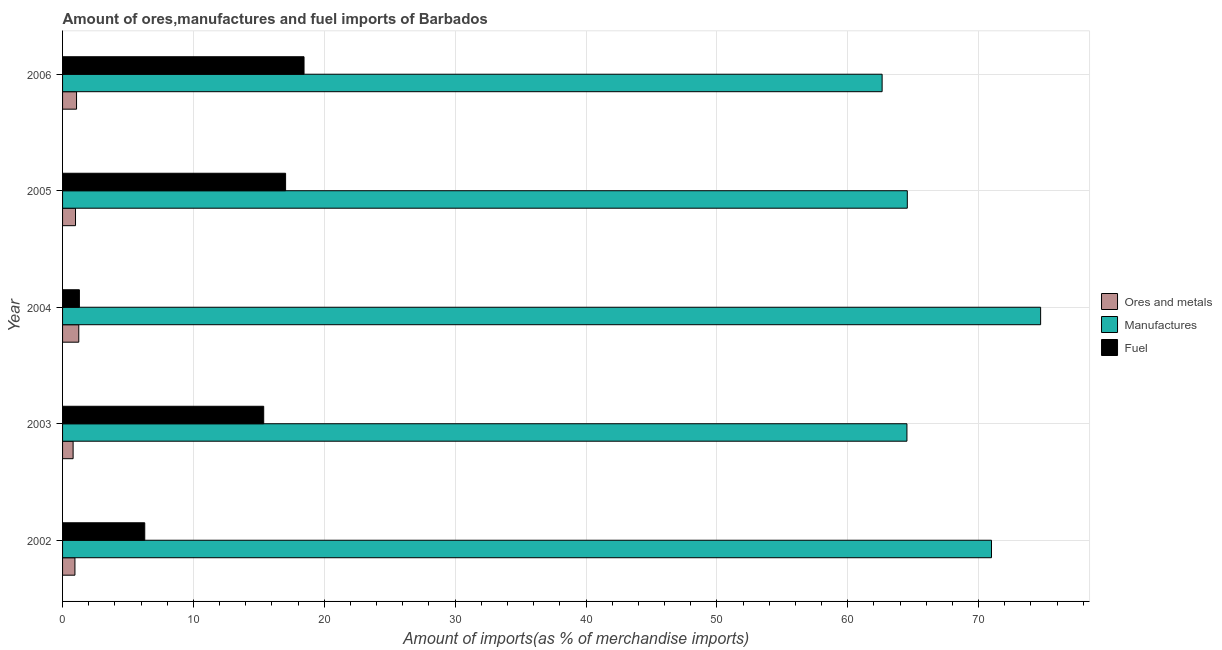How many groups of bars are there?
Your response must be concise. 5. Are the number of bars on each tick of the Y-axis equal?
Offer a terse response. Yes. How many bars are there on the 5th tick from the top?
Offer a very short reply. 3. How many bars are there on the 3rd tick from the bottom?
Your response must be concise. 3. In how many cases, is the number of bars for a given year not equal to the number of legend labels?
Give a very brief answer. 0. What is the percentage of fuel imports in 2004?
Give a very brief answer. 1.29. Across all years, what is the maximum percentage of ores and metals imports?
Make the answer very short. 1.24. Across all years, what is the minimum percentage of ores and metals imports?
Ensure brevity in your answer.  0.81. In which year was the percentage of ores and metals imports minimum?
Ensure brevity in your answer.  2003. What is the total percentage of manufactures imports in the graph?
Keep it short and to the point. 337.42. What is the difference between the percentage of ores and metals imports in 2003 and that in 2004?
Your answer should be very brief. -0.43. What is the difference between the percentage of ores and metals imports in 2004 and the percentage of manufactures imports in 2002?
Offer a very short reply. -69.74. What is the average percentage of manufactures imports per year?
Offer a terse response. 67.48. In the year 2003, what is the difference between the percentage of manufactures imports and percentage of ores and metals imports?
Your answer should be compact. 63.72. In how many years, is the percentage of manufactures imports greater than 12 %?
Offer a very short reply. 5. What is the ratio of the percentage of fuel imports in 2002 to that in 2005?
Offer a terse response. 0.37. Is the difference between the percentage of manufactures imports in 2005 and 2006 greater than the difference between the percentage of ores and metals imports in 2005 and 2006?
Give a very brief answer. Yes. What is the difference between the highest and the second highest percentage of fuel imports?
Give a very brief answer. 1.41. What is the difference between the highest and the lowest percentage of manufactures imports?
Keep it short and to the point. 12.11. What does the 2nd bar from the top in 2002 represents?
Your answer should be compact. Manufactures. What does the 1st bar from the bottom in 2003 represents?
Ensure brevity in your answer.  Ores and metals. Is it the case that in every year, the sum of the percentage of ores and metals imports and percentage of manufactures imports is greater than the percentage of fuel imports?
Make the answer very short. Yes. Are all the bars in the graph horizontal?
Your answer should be compact. Yes. Where does the legend appear in the graph?
Give a very brief answer. Center right. What is the title of the graph?
Keep it short and to the point. Amount of ores,manufactures and fuel imports of Barbados. Does "Taxes on income" appear as one of the legend labels in the graph?
Your response must be concise. No. What is the label or title of the X-axis?
Your response must be concise. Amount of imports(as % of merchandise imports). What is the Amount of imports(as % of merchandise imports) in Ores and metals in 2002?
Offer a terse response. 0.95. What is the Amount of imports(as % of merchandise imports) in Manufactures in 2002?
Keep it short and to the point. 70.98. What is the Amount of imports(as % of merchandise imports) in Fuel in 2002?
Offer a terse response. 6.28. What is the Amount of imports(as % of merchandise imports) in Ores and metals in 2003?
Provide a short and direct response. 0.81. What is the Amount of imports(as % of merchandise imports) of Manufactures in 2003?
Your answer should be compact. 64.52. What is the Amount of imports(as % of merchandise imports) of Fuel in 2003?
Give a very brief answer. 15.37. What is the Amount of imports(as % of merchandise imports) in Ores and metals in 2004?
Ensure brevity in your answer.  1.24. What is the Amount of imports(as % of merchandise imports) of Manufactures in 2004?
Offer a terse response. 74.74. What is the Amount of imports(as % of merchandise imports) of Fuel in 2004?
Keep it short and to the point. 1.29. What is the Amount of imports(as % of merchandise imports) of Ores and metals in 2005?
Give a very brief answer. 0.99. What is the Amount of imports(as % of merchandise imports) of Manufactures in 2005?
Your answer should be compact. 64.55. What is the Amount of imports(as % of merchandise imports) of Fuel in 2005?
Offer a terse response. 17.04. What is the Amount of imports(as % of merchandise imports) in Ores and metals in 2006?
Your answer should be compact. 1.07. What is the Amount of imports(as % of merchandise imports) in Manufactures in 2006?
Ensure brevity in your answer.  62.63. What is the Amount of imports(as % of merchandise imports) in Fuel in 2006?
Your response must be concise. 18.45. Across all years, what is the maximum Amount of imports(as % of merchandise imports) of Ores and metals?
Offer a very short reply. 1.24. Across all years, what is the maximum Amount of imports(as % of merchandise imports) in Manufactures?
Make the answer very short. 74.74. Across all years, what is the maximum Amount of imports(as % of merchandise imports) in Fuel?
Your response must be concise. 18.45. Across all years, what is the minimum Amount of imports(as % of merchandise imports) in Ores and metals?
Offer a very short reply. 0.81. Across all years, what is the minimum Amount of imports(as % of merchandise imports) of Manufactures?
Keep it short and to the point. 62.63. Across all years, what is the minimum Amount of imports(as % of merchandise imports) of Fuel?
Offer a very short reply. 1.29. What is the total Amount of imports(as % of merchandise imports) of Ores and metals in the graph?
Keep it short and to the point. 5.05. What is the total Amount of imports(as % of merchandise imports) in Manufactures in the graph?
Your answer should be very brief. 337.42. What is the total Amount of imports(as % of merchandise imports) of Fuel in the graph?
Provide a short and direct response. 58.43. What is the difference between the Amount of imports(as % of merchandise imports) of Ores and metals in 2002 and that in 2003?
Provide a short and direct response. 0.14. What is the difference between the Amount of imports(as % of merchandise imports) in Manufactures in 2002 and that in 2003?
Your answer should be compact. 6.46. What is the difference between the Amount of imports(as % of merchandise imports) of Fuel in 2002 and that in 2003?
Provide a short and direct response. -9.09. What is the difference between the Amount of imports(as % of merchandise imports) in Ores and metals in 2002 and that in 2004?
Your answer should be compact. -0.29. What is the difference between the Amount of imports(as % of merchandise imports) in Manufactures in 2002 and that in 2004?
Keep it short and to the point. -3.75. What is the difference between the Amount of imports(as % of merchandise imports) in Fuel in 2002 and that in 2004?
Keep it short and to the point. 4.99. What is the difference between the Amount of imports(as % of merchandise imports) of Ores and metals in 2002 and that in 2005?
Offer a terse response. -0.04. What is the difference between the Amount of imports(as % of merchandise imports) in Manufactures in 2002 and that in 2005?
Your response must be concise. 6.43. What is the difference between the Amount of imports(as % of merchandise imports) of Fuel in 2002 and that in 2005?
Ensure brevity in your answer.  -10.76. What is the difference between the Amount of imports(as % of merchandise imports) of Ores and metals in 2002 and that in 2006?
Your answer should be compact. -0.12. What is the difference between the Amount of imports(as % of merchandise imports) in Manufactures in 2002 and that in 2006?
Offer a terse response. 8.36. What is the difference between the Amount of imports(as % of merchandise imports) in Fuel in 2002 and that in 2006?
Provide a succinct answer. -12.17. What is the difference between the Amount of imports(as % of merchandise imports) of Ores and metals in 2003 and that in 2004?
Keep it short and to the point. -0.43. What is the difference between the Amount of imports(as % of merchandise imports) of Manufactures in 2003 and that in 2004?
Give a very brief answer. -10.22. What is the difference between the Amount of imports(as % of merchandise imports) of Fuel in 2003 and that in 2004?
Keep it short and to the point. 14.08. What is the difference between the Amount of imports(as % of merchandise imports) of Ores and metals in 2003 and that in 2005?
Make the answer very short. -0.18. What is the difference between the Amount of imports(as % of merchandise imports) of Manufactures in 2003 and that in 2005?
Keep it short and to the point. -0.03. What is the difference between the Amount of imports(as % of merchandise imports) of Fuel in 2003 and that in 2005?
Provide a short and direct response. -1.67. What is the difference between the Amount of imports(as % of merchandise imports) of Ores and metals in 2003 and that in 2006?
Offer a terse response. -0.26. What is the difference between the Amount of imports(as % of merchandise imports) in Manufactures in 2003 and that in 2006?
Give a very brief answer. 1.9. What is the difference between the Amount of imports(as % of merchandise imports) in Fuel in 2003 and that in 2006?
Offer a very short reply. -3.08. What is the difference between the Amount of imports(as % of merchandise imports) of Ores and metals in 2004 and that in 2005?
Offer a terse response. 0.25. What is the difference between the Amount of imports(as % of merchandise imports) of Manufactures in 2004 and that in 2005?
Ensure brevity in your answer.  10.19. What is the difference between the Amount of imports(as % of merchandise imports) of Fuel in 2004 and that in 2005?
Keep it short and to the point. -15.76. What is the difference between the Amount of imports(as % of merchandise imports) of Ores and metals in 2004 and that in 2006?
Provide a short and direct response. 0.17. What is the difference between the Amount of imports(as % of merchandise imports) in Manufactures in 2004 and that in 2006?
Provide a short and direct response. 12.11. What is the difference between the Amount of imports(as % of merchandise imports) in Fuel in 2004 and that in 2006?
Your answer should be very brief. -17.17. What is the difference between the Amount of imports(as % of merchandise imports) in Ores and metals in 2005 and that in 2006?
Your answer should be very brief. -0.08. What is the difference between the Amount of imports(as % of merchandise imports) of Manufactures in 2005 and that in 2006?
Your answer should be compact. 1.92. What is the difference between the Amount of imports(as % of merchandise imports) of Fuel in 2005 and that in 2006?
Give a very brief answer. -1.41. What is the difference between the Amount of imports(as % of merchandise imports) of Ores and metals in 2002 and the Amount of imports(as % of merchandise imports) of Manufactures in 2003?
Ensure brevity in your answer.  -63.58. What is the difference between the Amount of imports(as % of merchandise imports) of Ores and metals in 2002 and the Amount of imports(as % of merchandise imports) of Fuel in 2003?
Give a very brief answer. -14.42. What is the difference between the Amount of imports(as % of merchandise imports) of Manufactures in 2002 and the Amount of imports(as % of merchandise imports) of Fuel in 2003?
Provide a short and direct response. 55.61. What is the difference between the Amount of imports(as % of merchandise imports) of Ores and metals in 2002 and the Amount of imports(as % of merchandise imports) of Manufactures in 2004?
Give a very brief answer. -73.79. What is the difference between the Amount of imports(as % of merchandise imports) in Ores and metals in 2002 and the Amount of imports(as % of merchandise imports) in Fuel in 2004?
Offer a terse response. -0.34. What is the difference between the Amount of imports(as % of merchandise imports) of Manufactures in 2002 and the Amount of imports(as % of merchandise imports) of Fuel in 2004?
Your answer should be very brief. 69.7. What is the difference between the Amount of imports(as % of merchandise imports) in Ores and metals in 2002 and the Amount of imports(as % of merchandise imports) in Manufactures in 2005?
Offer a very short reply. -63.61. What is the difference between the Amount of imports(as % of merchandise imports) of Ores and metals in 2002 and the Amount of imports(as % of merchandise imports) of Fuel in 2005?
Make the answer very short. -16.1. What is the difference between the Amount of imports(as % of merchandise imports) in Manufactures in 2002 and the Amount of imports(as % of merchandise imports) in Fuel in 2005?
Ensure brevity in your answer.  53.94. What is the difference between the Amount of imports(as % of merchandise imports) in Ores and metals in 2002 and the Amount of imports(as % of merchandise imports) in Manufactures in 2006?
Offer a terse response. -61.68. What is the difference between the Amount of imports(as % of merchandise imports) of Ores and metals in 2002 and the Amount of imports(as % of merchandise imports) of Fuel in 2006?
Your answer should be very brief. -17.51. What is the difference between the Amount of imports(as % of merchandise imports) in Manufactures in 2002 and the Amount of imports(as % of merchandise imports) in Fuel in 2006?
Your answer should be compact. 52.53. What is the difference between the Amount of imports(as % of merchandise imports) of Ores and metals in 2003 and the Amount of imports(as % of merchandise imports) of Manufactures in 2004?
Your response must be concise. -73.93. What is the difference between the Amount of imports(as % of merchandise imports) of Ores and metals in 2003 and the Amount of imports(as % of merchandise imports) of Fuel in 2004?
Your response must be concise. -0.48. What is the difference between the Amount of imports(as % of merchandise imports) in Manufactures in 2003 and the Amount of imports(as % of merchandise imports) in Fuel in 2004?
Your answer should be compact. 63.24. What is the difference between the Amount of imports(as % of merchandise imports) of Ores and metals in 2003 and the Amount of imports(as % of merchandise imports) of Manufactures in 2005?
Your answer should be compact. -63.75. What is the difference between the Amount of imports(as % of merchandise imports) in Ores and metals in 2003 and the Amount of imports(as % of merchandise imports) in Fuel in 2005?
Your answer should be compact. -16.24. What is the difference between the Amount of imports(as % of merchandise imports) of Manufactures in 2003 and the Amount of imports(as % of merchandise imports) of Fuel in 2005?
Your answer should be very brief. 47.48. What is the difference between the Amount of imports(as % of merchandise imports) of Ores and metals in 2003 and the Amount of imports(as % of merchandise imports) of Manufactures in 2006?
Your response must be concise. -61.82. What is the difference between the Amount of imports(as % of merchandise imports) of Ores and metals in 2003 and the Amount of imports(as % of merchandise imports) of Fuel in 2006?
Your answer should be very brief. -17.65. What is the difference between the Amount of imports(as % of merchandise imports) of Manufactures in 2003 and the Amount of imports(as % of merchandise imports) of Fuel in 2006?
Ensure brevity in your answer.  46.07. What is the difference between the Amount of imports(as % of merchandise imports) of Ores and metals in 2004 and the Amount of imports(as % of merchandise imports) of Manufactures in 2005?
Provide a succinct answer. -63.31. What is the difference between the Amount of imports(as % of merchandise imports) of Ores and metals in 2004 and the Amount of imports(as % of merchandise imports) of Fuel in 2005?
Give a very brief answer. -15.8. What is the difference between the Amount of imports(as % of merchandise imports) in Manufactures in 2004 and the Amount of imports(as % of merchandise imports) in Fuel in 2005?
Provide a short and direct response. 57.7. What is the difference between the Amount of imports(as % of merchandise imports) of Ores and metals in 2004 and the Amount of imports(as % of merchandise imports) of Manufactures in 2006?
Give a very brief answer. -61.39. What is the difference between the Amount of imports(as % of merchandise imports) in Ores and metals in 2004 and the Amount of imports(as % of merchandise imports) in Fuel in 2006?
Give a very brief answer. -17.21. What is the difference between the Amount of imports(as % of merchandise imports) in Manufactures in 2004 and the Amount of imports(as % of merchandise imports) in Fuel in 2006?
Offer a terse response. 56.29. What is the difference between the Amount of imports(as % of merchandise imports) of Ores and metals in 2005 and the Amount of imports(as % of merchandise imports) of Manufactures in 2006?
Your answer should be compact. -61.64. What is the difference between the Amount of imports(as % of merchandise imports) in Ores and metals in 2005 and the Amount of imports(as % of merchandise imports) in Fuel in 2006?
Your response must be concise. -17.46. What is the difference between the Amount of imports(as % of merchandise imports) of Manufactures in 2005 and the Amount of imports(as % of merchandise imports) of Fuel in 2006?
Keep it short and to the point. 46.1. What is the average Amount of imports(as % of merchandise imports) in Ores and metals per year?
Your answer should be compact. 1.01. What is the average Amount of imports(as % of merchandise imports) of Manufactures per year?
Provide a succinct answer. 67.48. What is the average Amount of imports(as % of merchandise imports) in Fuel per year?
Your response must be concise. 11.69. In the year 2002, what is the difference between the Amount of imports(as % of merchandise imports) in Ores and metals and Amount of imports(as % of merchandise imports) in Manufactures?
Offer a very short reply. -70.04. In the year 2002, what is the difference between the Amount of imports(as % of merchandise imports) in Ores and metals and Amount of imports(as % of merchandise imports) in Fuel?
Your response must be concise. -5.33. In the year 2002, what is the difference between the Amount of imports(as % of merchandise imports) of Manufactures and Amount of imports(as % of merchandise imports) of Fuel?
Your answer should be very brief. 64.7. In the year 2003, what is the difference between the Amount of imports(as % of merchandise imports) in Ores and metals and Amount of imports(as % of merchandise imports) in Manufactures?
Ensure brevity in your answer.  -63.72. In the year 2003, what is the difference between the Amount of imports(as % of merchandise imports) in Ores and metals and Amount of imports(as % of merchandise imports) in Fuel?
Ensure brevity in your answer.  -14.56. In the year 2003, what is the difference between the Amount of imports(as % of merchandise imports) of Manufactures and Amount of imports(as % of merchandise imports) of Fuel?
Keep it short and to the point. 49.15. In the year 2004, what is the difference between the Amount of imports(as % of merchandise imports) of Ores and metals and Amount of imports(as % of merchandise imports) of Manufactures?
Offer a terse response. -73.5. In the year 2004, what is the difference between the Amount of imports(as % of merchandise imports) in Ores and metals and Amount of imports(as % of merchandise imports) in Fuel?
Make the answer very short. -0.05. In the year 2004, what is the difference between the Amount of imports(as % of merchandise imports) in Manufactures and Amount of imports(as % of merchandise imports) in Fuel?
Your answer should be very brief. 73.45. In the year 2005, what is the difference between the Amount of imports(as % of merchandise imports) in Ores and metals and Amount of imports(as % of merchandise imports) in Manufactures?
Make the answer very short. -63.56. In the year 2005, what is the difference between the Amount of imports(as % of merchandise imports) in Ores and metals and Amount of imports(as % of merchandise imports) in Fuel?
Make the answer very short. -16.05. In the year 2005, what is the difference between the Amount of imports(as % of merchandise imports) of Manufactures and Amount of imports(as % of merchandise imports) of Fuel?
Keep it short and to the point. 47.51. In the year 2006, what is the difference between the Amount of imports(as % of merchandise imports) in Ores and metals and Amount of imports(as % of merchandise imports) in Manufactures?
Your answer should be compact. -61.56. In the year 2006, what is the difference between the Amount of imports(as % of merchandise imports) in Ores and metals and Amount of imports(as % of merchandise imports) in Fuel?
Your answer should be compact. -17.38. In the year 2006, what is the difference between the Amount of imports(as % of merchandise imports) of Manufactures and Amount of imports(as % of merchandise imports) of Fuel?
Provide a short and direct response. 44.17. What is the ratio of the Amount of imports(as % of merchandise imports) of Ores and metals in 2002 to that in 2003?
Offer a terse response. 1.17. What is the ratio of the Amount of imports(as % of merchandise imports) of Manufactures in 2002 to that in 2003?
Make the answer very short. 1.1. What is the ratio of the Amount of imports(as % of merchandise imports) of Fuel in 2002 to that in 2003?
Your response must be concise. 0.41. What is the ratio of the Amount of imports(as % of merchandise imports) in Ores and metals in 2002 to that in 2004?
Provide a short and direct response. 0.76. What is the ratio of the Amount of imports(as % of merchandise imports) of Manufactures in 2002 to that in 2004?
Your answer should be very brief. 0.95. What is the ratio of the Amount of imports(as % of merchandise imports) in Fuel in 2002 to that in 2004?
Offer a very short reply. 4.88. What is the ratio of the Amount of imports(as % of merchandise imports) of Ores and metals in 2002 to that in 2005?
Offer a terse response. 0.96. What is the ratio of the Amount of imports(as % of merchandise imports) in Manufactures in 2002 to that in 2005?
Your answer should be very brief. 1.1. What is the ratio of the Amount of imports(as % of merchandise imports) of Fuel in 2002 to that in 2005?
Offer a terse response. 0.37. What is the ratio of the Amount of imports(as % of merchandise imports) of Ores and metals in 2002 to that in 2006?
Offer a very short reply. 0.88. What is the ratio of the Amount of imports(as % of merchandise imports) in Manufactures in 2002 to that in 2006?
Offer a very short reply. 1.13. What is the ratio of the Amount of imports(as % of merchandise imports) of Fuel in 2002 to that in 2006?
Offer a very short reply. 0.34. What is the ratio of the Amount of imports(as % of merchandise imports) of Ores and metals in 2003 to that in 2004?
Provide a succinct answer. 0.65. What is the ratio of the Amount of imports(as % of merchandise imports) of Manufactures in 2003 to that in 2004?
Your answer should be very brief. 0.86. What is the ratio of the Amount of imports(as % of merchandise imports) in Fuel in 2003 to that in 2004?
Provide a short and direct response. 11.95. What is the ratio of the Amount of imports(as % of merchandise imports) in Ores and metals in 2003 to that in 2005?
Offer a terse response. 0.81. What is the ratio of the Amount of imports(as % of merchandise imports) of Fuel in 2003 to that in 2005?
Provide a short and direct response. 0.9. What is the ratio of the Amount of imports(as % of merchandise imports) of Ores and metals in 2003 to that in 2006?
Keep it short and to the point. 0.75. What is the ratio of the Amount of imports(as % of merchandise imports) in Manufactures in 2003 to that in 2006?
Offer a very short reply. 1.03. What is the ratio of the Amount of imports(as % of merchandise imports) of Fuel in 2003 to that in 2006?
Your answer should be compact. 0.83. What is the ratio of the Amount of imports(as % of merchandise imports) in Ores and metals in 2004 to that in 2005?
Ensure brevity in your answer.  1.25. What is the ratio of the Amount of imports(as % of merchandise imports) in Manufactures in 2004 to that in 2005?
Ensure brevity in your answer.  1.16. What is the ratio of the Amount of imports(as % of merchandise imports) in Fuel in 2004 to that in 2005?
Give a very brief answer. 0.08. What is the ratio of the Amount of imports(as % of merchandise imports) in Ores and metals in 2004 to that in 2006?
Offer a terse response. 1.16. What is the ratio of the Amount of imports(as % of merchandise imports) of Manufactures in 2004 to that in 2006?
Offer a terse response. 1.19. What is the ratio of the Amount of imports(as % of merchandise imports) of Fuel in 2004 to that in 2006?
Provide a succinct answer. 0.07. What is the ratio of the Amount of imports(as % of merchandise imports) of Ores and metals in 2005 to that in 2006?
Offer a very short reply. 0.93. What is the ratio of the Amount of imports(as % of merchandise imports) of Manufactures in 2005 to that in 2006?
Give a very brief answer. 1.03. What is the ratio of the Amount of imports(as % of merchandise imports) of Fuel in 2005 to that in 2006?
Offer a terse response. 0.92. What is the difference between the highest and the second highest Amount of imports(as % of merchandise imports) of Ores and metals?
Your answer should be very brief. 0.17. What is the difference between the highest and the second highest Amount of imports(as % of merchandise imports) of Manufactures?
Keep it short and to the point. 3.75. What is the difference between the highest and the second highest Amount of imports(as % of merchandise imports) in Fuel?
Provide a short and direct response. 1.41. What is the difference between the highest and the lowest Amount of imports(as % of merchandise imports) in Ores and metals?
Offer a terse response. 0.43. What is the difference between the highest and the lowest Amount of imports(as % of merchandise imports) in Manufactures?
Keep it short and to the point. 12.11. What is the difference between the highest and the lowest Amount of imports(as % of merchandise imports) in Fuel?
Offer a very short reply. 17.17. 